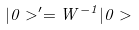<formula> <loc_0><loc_0><loc_500><loc_500>| 0 > ^ { \prime } = W ^ { - 1 } | 0 ></formula> 